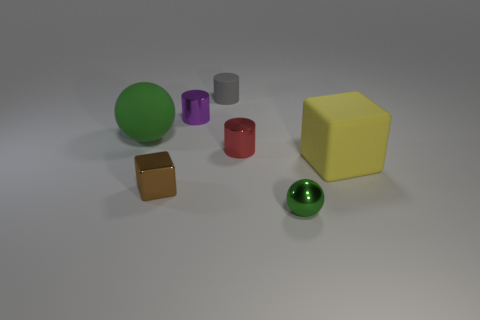Subtract all metallic cylinders. How many cylinders are left? 1 Add 2 big matte objects. How many objects exist? 9 Subtract all gray cylinders. How many cylinders are left? 2 Subtract 1 cylinders. How many cylinders are left? 2 Subtract 0 purple cubes. How many objects are left? 7 Subtract all balls. How many objects are left? 5 Subtract all blue cubes. Subtract all cyan cylinders. How many cubes are left? 2 Subtract all brown cubes. How many gray balls are left? 0 Subtract all tiny purple things. Subtract all red metallic blocks. How many objects are left? 6 Add 5 large matte balls. How many large matte balls are left? 6 